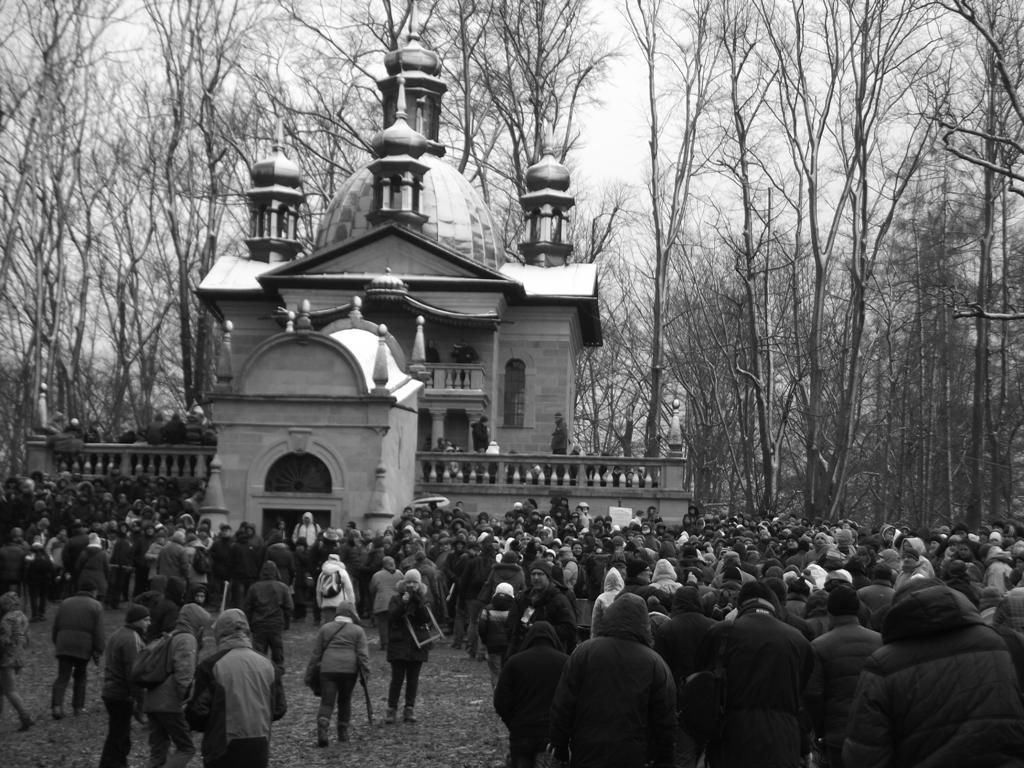Can you describe this image briefly? This is a black and white image. In this image we can see many people. In the back there is a building. In the background there are trees. Also there is sky. 